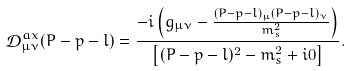Convert formula to latex. <formula><loc_0><loc_0><loc_500><loc_500>\mathcal { D } _ { \mu \nu } ^ { a x } ( P - p - l ) = \frac { - i \left ( g _ { \mu \nu } - \frac { ( P - p - l ) _ { \mu } ( P - p - l ) _ { \nu } } { m _ { s } ^ { 2 } } \right ) } { \left [ ( P - p - l ) ^ { 2 } - m _ { s } ^ { 2 } + i 0 \right ] } .</formula> 